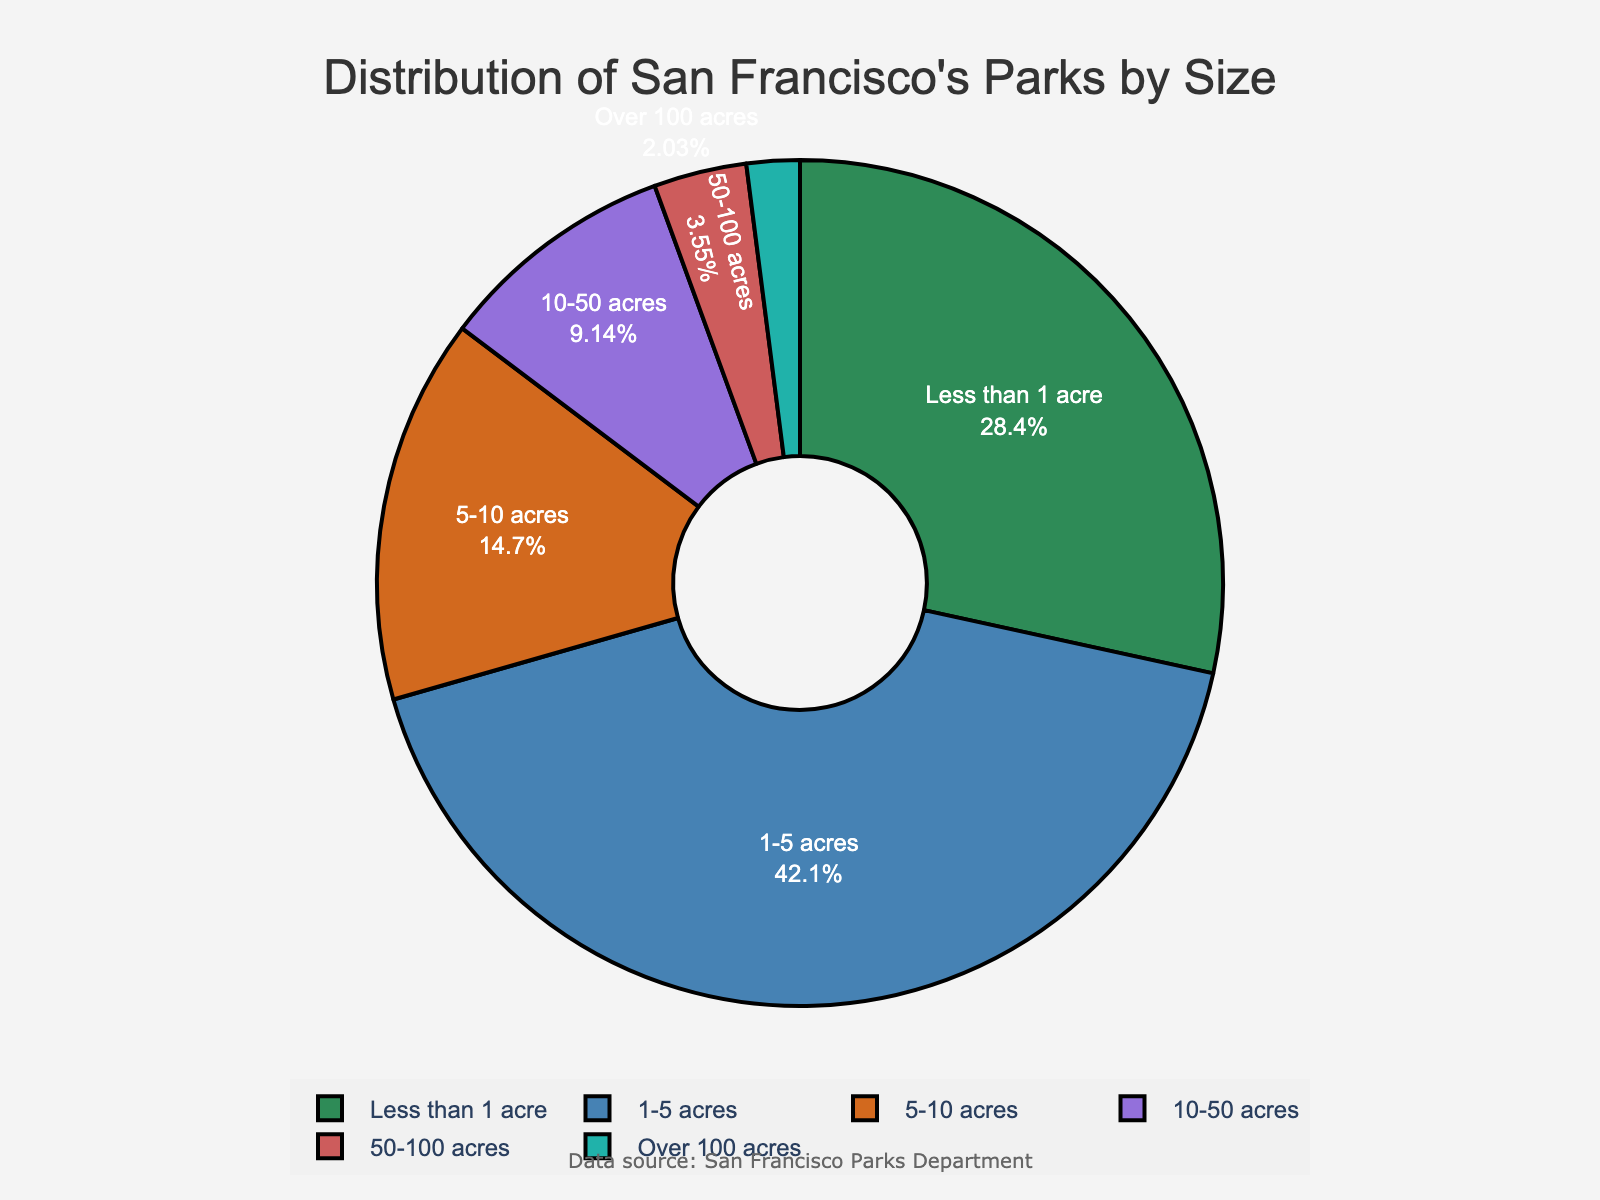What is the size category with the largest number of parks? The largest number of parks will have the biggest sector in the pie chart. By looking at the chart, the "1-5 acres" category occupies the largest portion.
Answer: 1-5 acres Which size category has the smallest number of parks? The smallest number of parks will have the smallest sector in the pie chart. By observing the chart, the "Over 100 acres" category is the smallest.
Answer: Over 100 acres What percentage of parks are less than 1 acre? This can be directly read from the chart as it should display both the label and percentage for each sector.
Answer: 25.1% How many parks have more than 50 acres? To determine this, add the number of parks in the "50-100 acres" and "Over 100 acres" categories. From the chart, respectively, these are 7 and 4 parks. 7 + 4 = 11.
Answer: 11 Compare the number of parks in the "5-10 acres" category to the "10-50 acres" category. Which one is greater? By comparing the portions in the pie chart, the "5-10 acres" sector is larger than the "10-50 acres" sector. The respective numbers are 29 and 18.
Answer: 5-10 acres What is the combined percentage of parks that are between 1 and 10 acres? Add the percentages of the "1-5 acres" and "5-10 acres" categories. The chart should display these as 37.2% and 13.0%. Thus, 37.2% + 13.0% = 50.2%.
Answer: 50.2% If you were to merge the "50-100 acres" and "Over 100 acres" categories, how many total categories would appear in the chart? If "50-100 acres" and "Over 100 acres" are merged, there will be one fewer category in the chart. Initially, there are 6 categories, so there will be 6 - 1 = 5 categories.
Answer: 5 What is the difference in the number of parks between the "Less than 1 acre" and "1-5 acres" categories? Subtract the number of parks in the "Less than 1 acre" category from the "1-5 acres" category. The respective numbers are 83 and 56. Thus, 83 - 56 = 27.
Answer: 27 What is the percentage of parks that have less than 10 acres in total? Sum the percentages of the "Less than 1 acre", "1-5 acres", and "5-10 acres" categories. The chart should display these as 25.1%, 37.2%, and 13.0%. Thus, 25.1% + 37.2% + 13.0% = 75.3%.
Answer: 75.3% If a new category "10-20 acres" is created from splitting "10-50 acres", assuming it's evenly split in number, how many parks will be in each new category? The "10-50 acres" category has 18 parks. If evenly split into "10-20 acres" and "20-50 acres", each new category would have 18 / 2 = 9 parks.
Answer: 9 